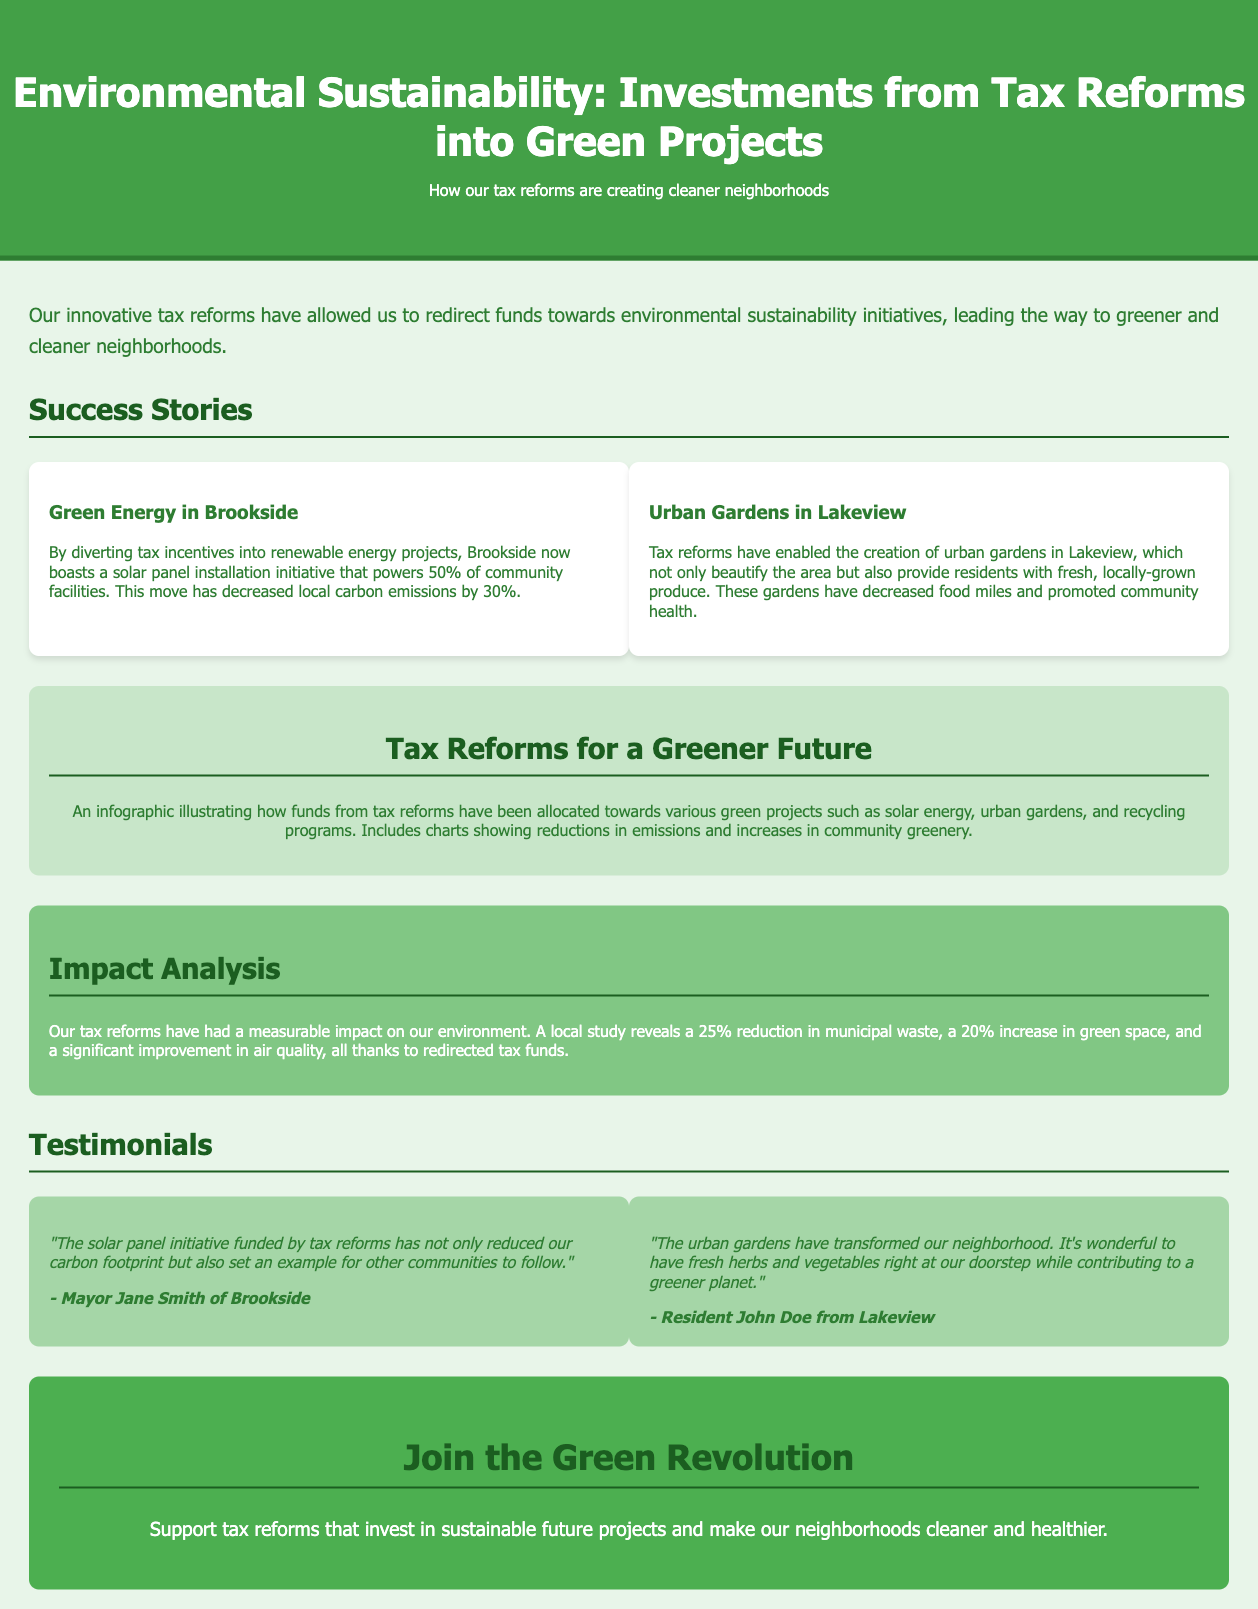What is the title of the advertisement? The title of the advertisement is prominently displayed at the top of the document.
Answer: Environmental Sustainability: Investments from Tax Reforms into Green Projects How much has local carbon emissions decreased in Brookside? The document mentions a specific percentage decrease in carbon emissions due to green projects in Brookside.
Answer: 30% What percentage of community facilities is powered by solar panels in Brookside? This information is highlighted in the success story related to Brookside.
Answer: 50% What is the main benefit of the urban gardens in Lakeview? The document describes the primary advantage of urban gardens for residents in Lakeview.
Answer: Fresh, locally-grown produce What has been the reduction in municipal waste due to tax reforms? The impact analysis section provides a specific percentage for waste reduction.
Answer: 25% What does the infographic illustrate? The infographic visually summarizes the allocation of tax reform funds towards environmental projects.
Answer: Allocation of funds for green projects Who provided a testimonial about the solar panel initiative? There is a specific testimonial related to the solar panel initiative from a local authority.
Answer: Mayor Jane Smith What type of community initiative is mentioned alongside urban gardens? The document references various initiatives targeted at enhancing environmental sustainability.
Answer: Green Energy 